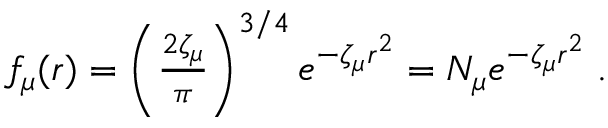<formula> <loc_0><loc_0><loc_500><loc_500>\begin{array} { r } { f _ { \mu } ( r ) = \left ( \frac { 2 \zeta _ { \mu } } { \pi } \right ) ^ { 3 / 4 } e ^ { - \zeta _ { \mu } r ^ { 2 } } = N _ { \mu } e ^ { - \zeta _ { \mu } r ^ { 2 } } \, . } \end{array}</formula> 